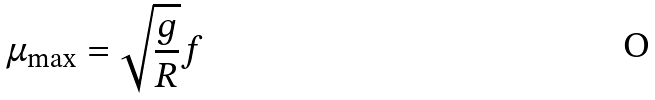Convert formula to latex. <formula><loc_0><loc_0><loc_500><loc_500>\mu _ { \max } = \sqrt { \frac { g } { R } } f</formula> 